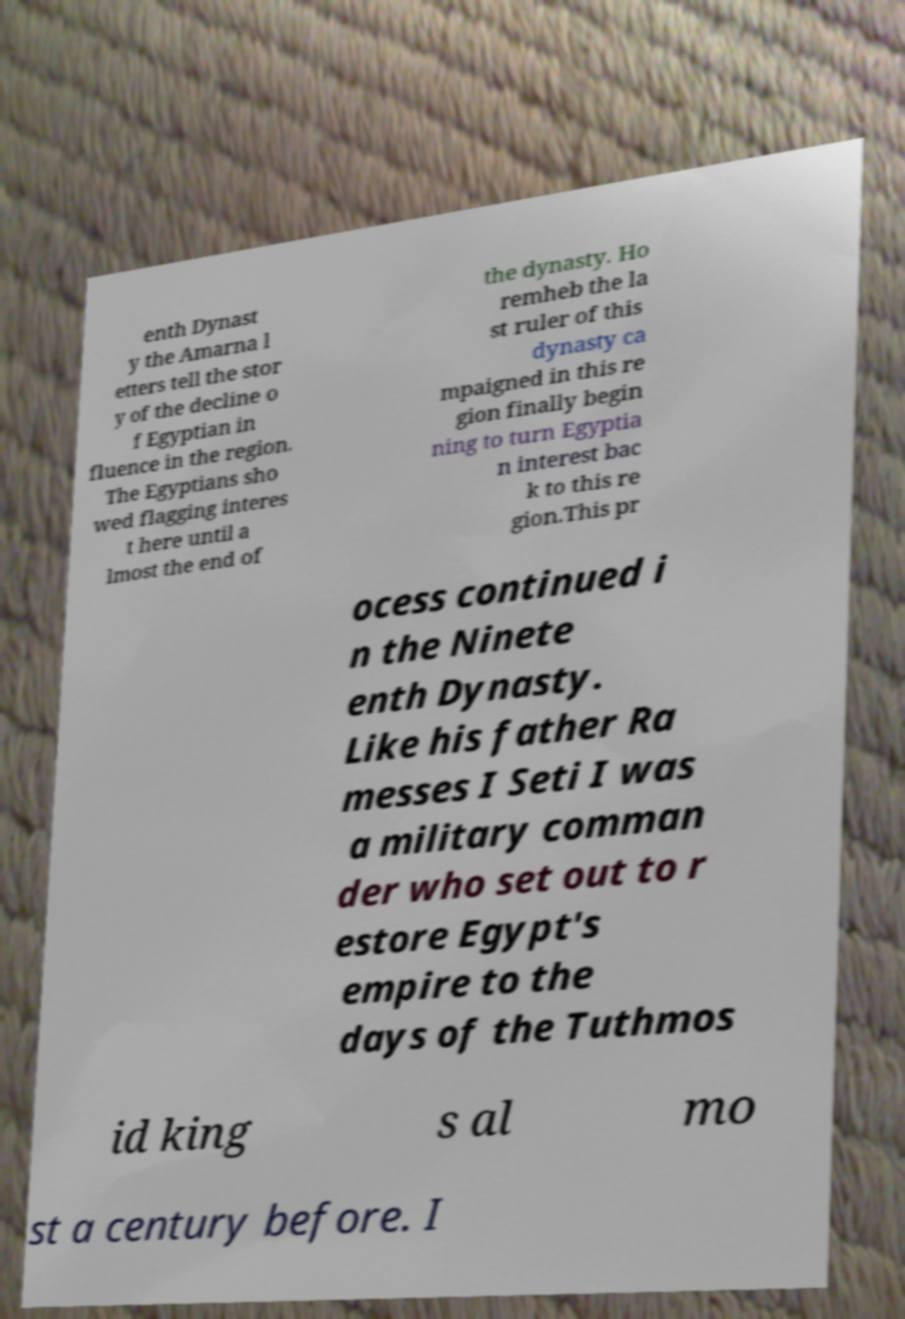What messages or text are displayed in this image? I need them in a readable, typed format. enth Dynast y the Amarna l etters tell the stor y of the decline o f Egyptian in fluence in the region. The Egyptians sho wed flagging interes t here until a lmost the end of the dynasty. Ho remheb the la st ruler of this dynasty ca mpaigned in this re gion finally begin ning to turn Egyptia n interest bac k to this re gion.This pr ocess continued i n the Ninete enth Dynasty. Like his father Ra messes I Seti I was a military comman der who set out to r estore Egypt's empire to the days of the Tuthmos id king s al mo st a century before. I 